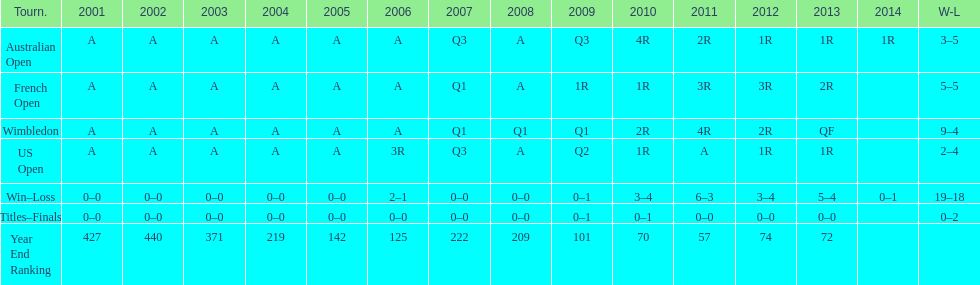What tournament has 5-5 as it's "w-l" record? French Open. 